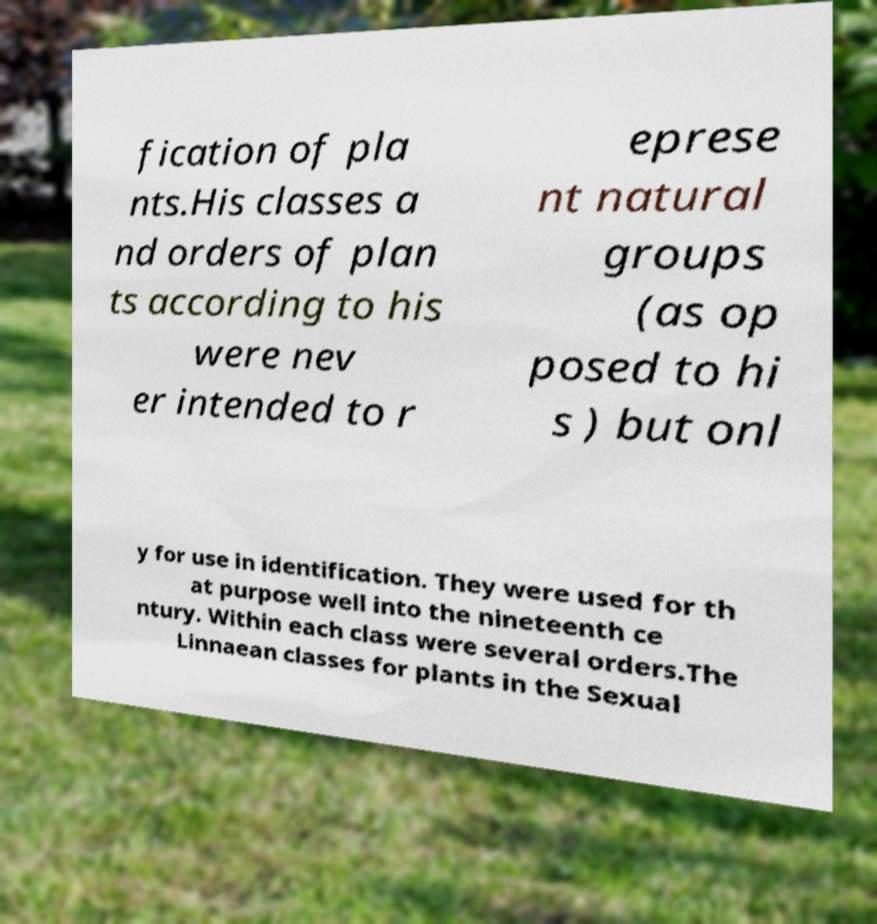I need the written content from this picture converted into text. Can you do that? fication of pla nts.His classes a nd orders of plan ts according to his were nev er intended to r eprese nt natural groups (as op posed to hi s ) but onl y for use in identification. They were used for th at purpose well into the nineteenth ce ntury. Within each class were several orders.The Linnaean classes for plants in the Sexual 